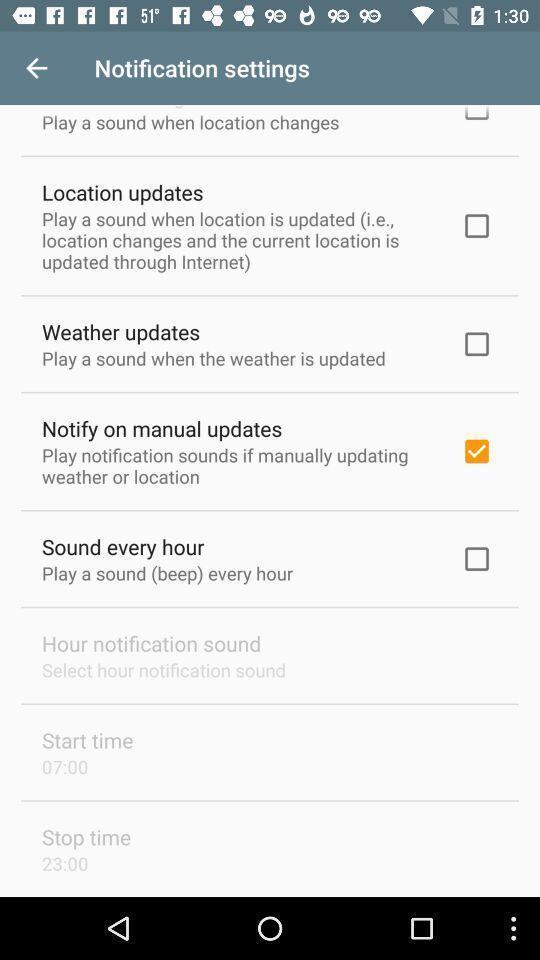Tell me what you see in this picture. Screen shows notification settings. 